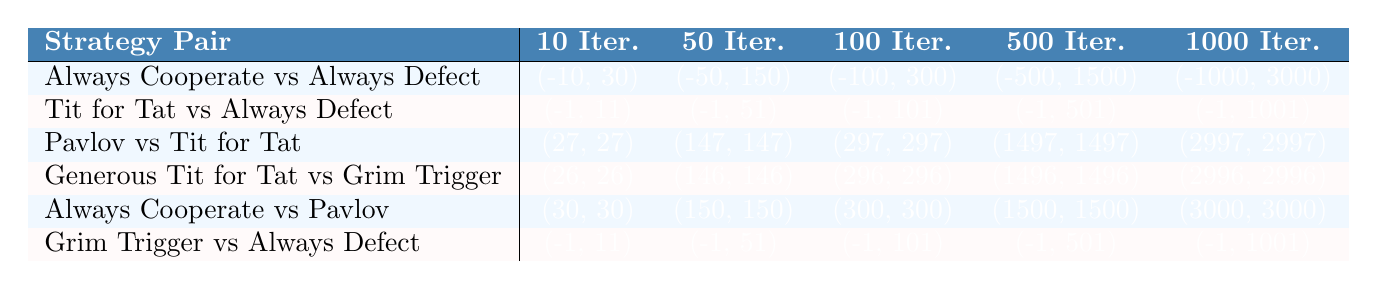What is the payoff for "Always Cooperate" when facing "Always Defect" in 100 iterations? According to the table, in the row for "Always Cooperate vs Always Defect" under 100 iterations, the payoff is listed as (-100, 300). The first value is the payoff for "Always Cooperate," which is -100.
Answer: -100 What is the payoff difference between "Pavlov" and "Tit for Tat" in 50 iterations? For "Pavlov vs Tit for Tat," the payoffs in the 50 iterations are (147, 147). Both players receive the same payoff of 147, so the difference is 147 - 147 = 0.
Answer: 0 Which strategy pair yields the highest total payoff after 1000 iterations? Looking at the last column under 1000 iterations, the payoffs for each strategy pair are: Always Cooperate vs Always Defect = -1000 + 3000 = 2000, Tit for Tat vs Always Defect = -1 + 1001 = 1000, Pavlov vs Tit for Tat = 2997 + 2997 = 5994, Generous Tit for Tat vs Grim Trigger = 2996 + 2996 = 5992, Always Cooperate vs Pavlov = 3000 + 3000 = 6000, Grim Trigger vs Always Defect = -1 + 1001 = 1000. The highest total is from "Always Cooperate vs Pavlov," which equals 6000.
Answer: Always Cooperate vs Pavlov How does the payoff of "Grim Trigger" change against "Always Defect" from 10 to 100 iterations? In the table, for "Grim Trigger vs Always Defect," the payoffs change from (-1, 11) for 10 iterations to (-1, 101) for 100 iterations. The payoff for "Grim Trigger" remains -1 while the payoff for "Always Defect" increases from 11 to 101.
Answer: Payoff for "Grim Trigger" remains -1, "Always Defect" increases from 11 to 101 Does "Generous Tit for Tat" always yield a better payoff than "Grim Trigger"? The payoffs for "Generous Tit for Tat vs Grim Trigger" are always (26, 26) across all iterations, while "Grim Trigger vs Always Defect" yields (-1, values) for different iterations. Since both get the same payoffs, "Generous Tit for Tat" does not always yield a better payoff than "Grim Trigger,” especially in the context of its match against "Always Defect."
Answer: No, not always What is the average payoff for "Pavlov" over all iterations when playing against "Tit for Tat"? The payoffs for "Pavlov vs Tit for Tat" across 10, 50, 100, 500, and 1000 iterations are 27, 147, 297, 1497, 2997. Summing these gives 27 + 147 + 297 + 1497 + 2997 = 4965. The average payoff is 4965/5 = 993.
Answer: 993 Which strategy pair shows the least favorable outcome in 500 iterations? In 500 iterations, the least favorable payoff from the pairs shows "Always Cooperate vs Always Defect" with a result of (-500, 1500). This indicates a negative outcome for the cooperating strategy compared to a significant positive payoff for the defecting strategy, which clearly marks it as the least favorable outcome.
Answer: Always Cooperate vs Always Defect What is the payoff trend for "Always Cooperate" across all iteration scenarios? By observing the table, "Always Cooperate" has the following payoffs: -10, -50, -100, -500, -1000. As we look at these values, we can see that the payoff consistently decreases with increasing iterations, indicating an overall negative trend.
Answer: It shows a decreasing trend 